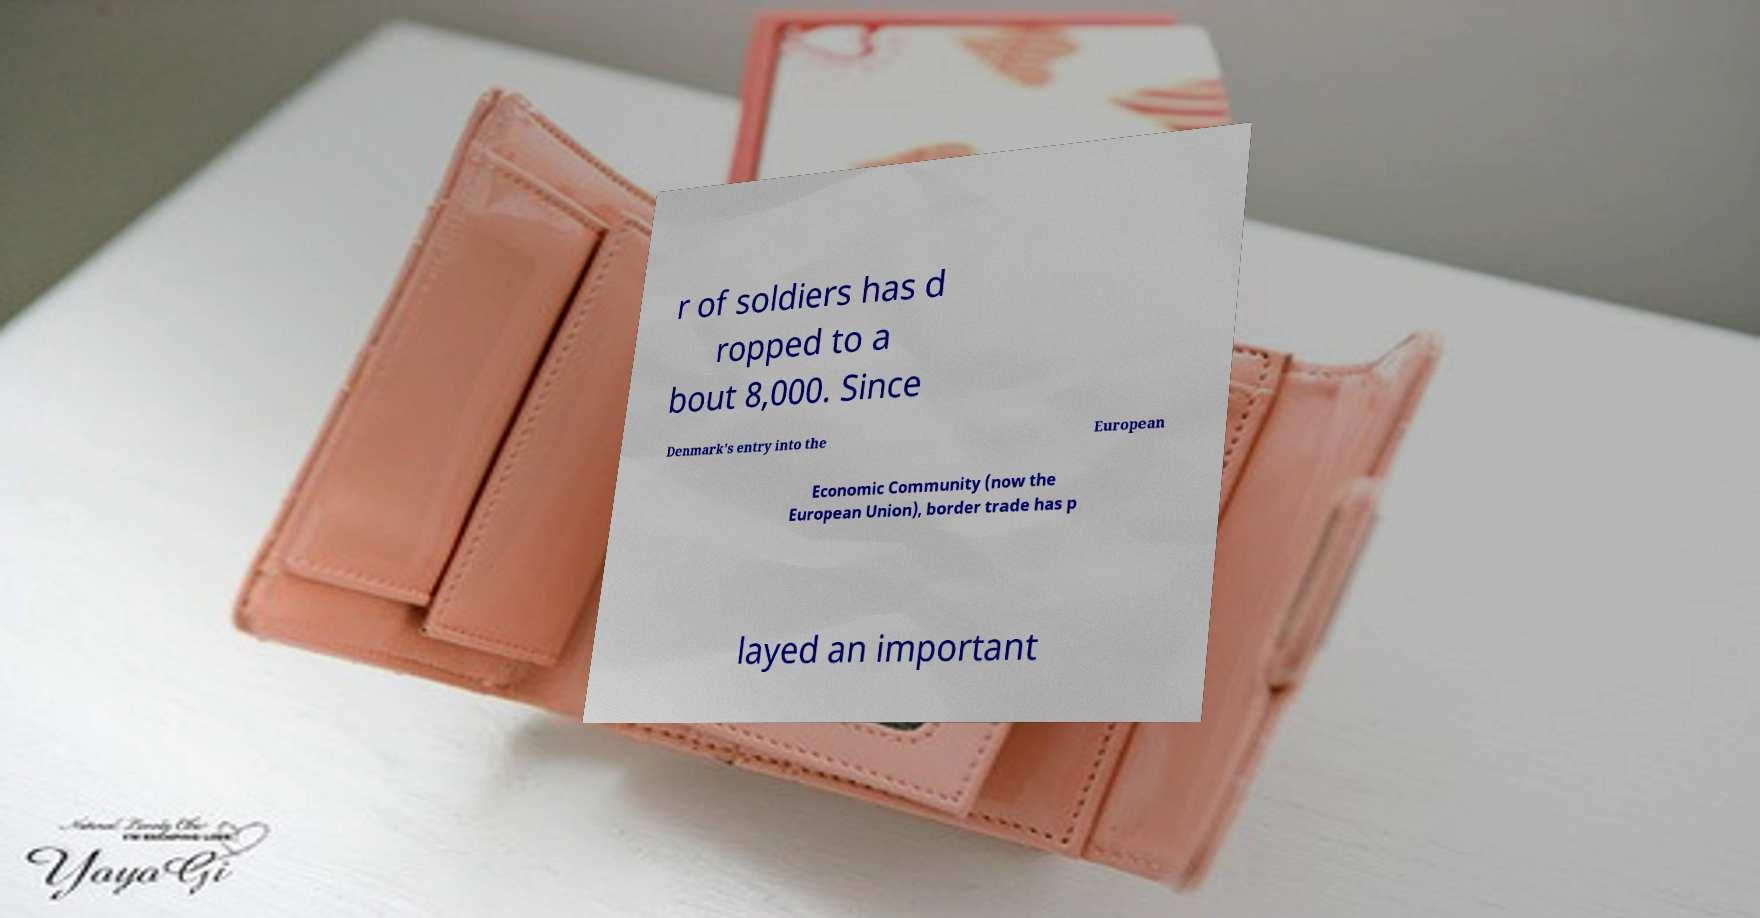Can you accurately transcribe the text from the provided image for me? r of soldiers has d ropped to a bout 8,000. Since Denmark's entry into the European Economic Community (now the European Union), border trade has p layed an important 